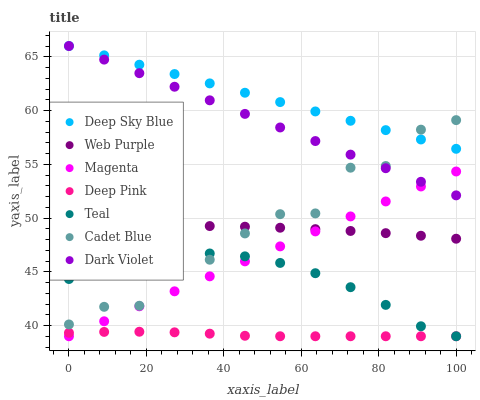Does Deep Pink have the minimum area under the curve?
Answer yes or no. Yes. Does Deep Sky Blue have the maximum area under the curve?
Answer yes or no. Yes. Does Dark Violet have the minimum area under the curve?
Answer yes or no. No. Does Dark Violet have the maximum area under the curve?
Answer yes or no. No. Is Magenta the smoothest?
Answer yes or no. Yes. Is Cadet Blue the roughest?
Answer yes or no. Yes. Is Deep Sky Blue the smoothest?
Answer yes or no. No. Is Deep Sky Blue the roughest?
Answer yes or no. No. Does Deep Pink have the lowest value?
Answer yes or no. Yes. Does Dark Violet have the lowest value?
Answer yes or no. No. Does Dark Violet have the highest value?
Answer yes or no. Yes. Does Web Purple have the highest value?
Answer yes or no. No. Is Teal less than Dark Violet?
Answer yes or no. Yes. Is Cadet Blue greater than Magenta?
Answer yes or no. Yes. Does Deep Pink intersect Teal?
Answer yes or no. Yes. Is Deep Pink less than Teal?
Answer yes or no. No. Is Deep Pink greater than Teal?
Answer yes or no. No. Does Teal intersect Dark Violet?
Answer yes or no. No. 